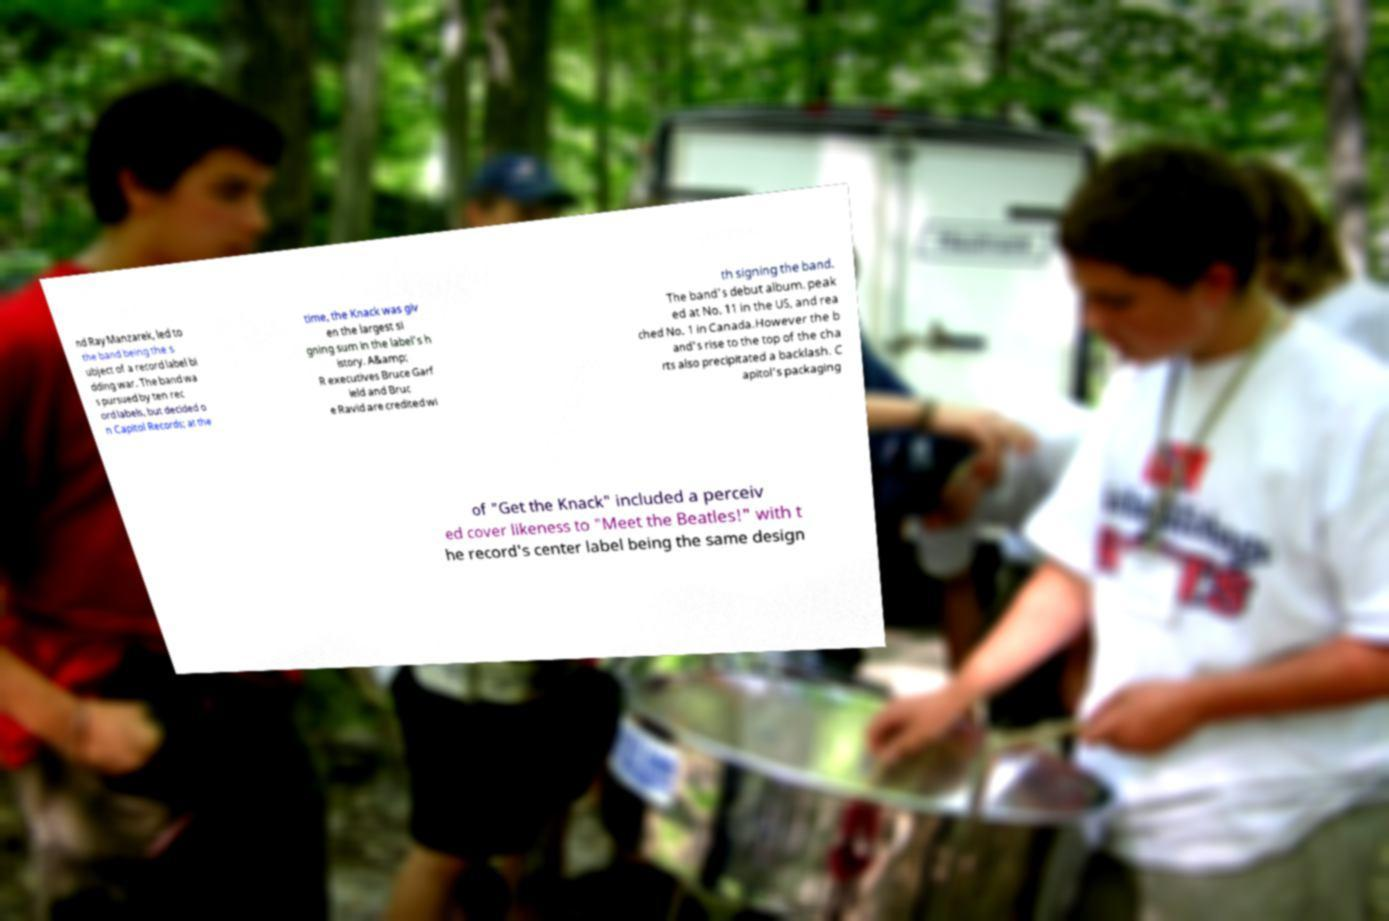Could you extract and type out the text from this image? nd Ray Manzarek, led to the band being the s ubject of a record label bi dding war. The band wa s pursued by ten rec ord labels, but decided o n Capitol Records; at the time, the Knack was giv en the largest si gning sum in the label's h istory. A&amp; R executives Bruce Garf ield and Bruc e Ravid are credited wi th signing the band. The band's debut album, peak ed at No. 11 in the US, and rea ched No. 1 in Canada.However the b and's rise to the top of the cha rts also precipitated a backlash. C apitol's packaging of "Get the Knack" included a perceiv ed cover likeness to "Meet the Beatles!" with t he record's center label being the same design 